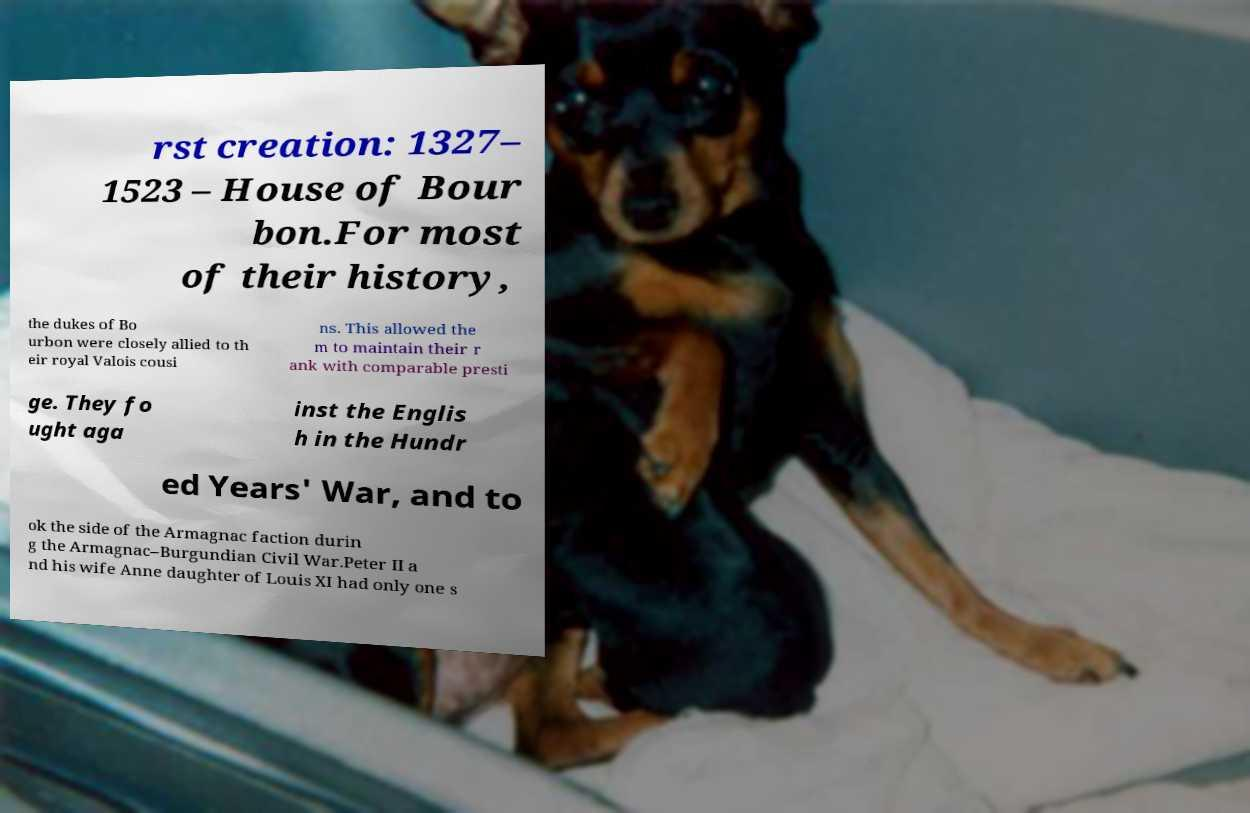What messages or text are displayed in this image? I need them in a readable, typed format. rst creation: 1327– 1523 – House of Bour bon.For most of their history, the dukes of Bo urbon were closely allied to th eir royal Valois cousi ns. This allowed the m to maintain their r ank with comparable presti ge. They fo ught aga inst the Englis h in the Hundr ed Years' War, and to ok the side of the Armagnac faction durin g the Armagnac–Burgundian Civil War.Peter II a nd his wife Anne daughter of Louis XI had only one s 